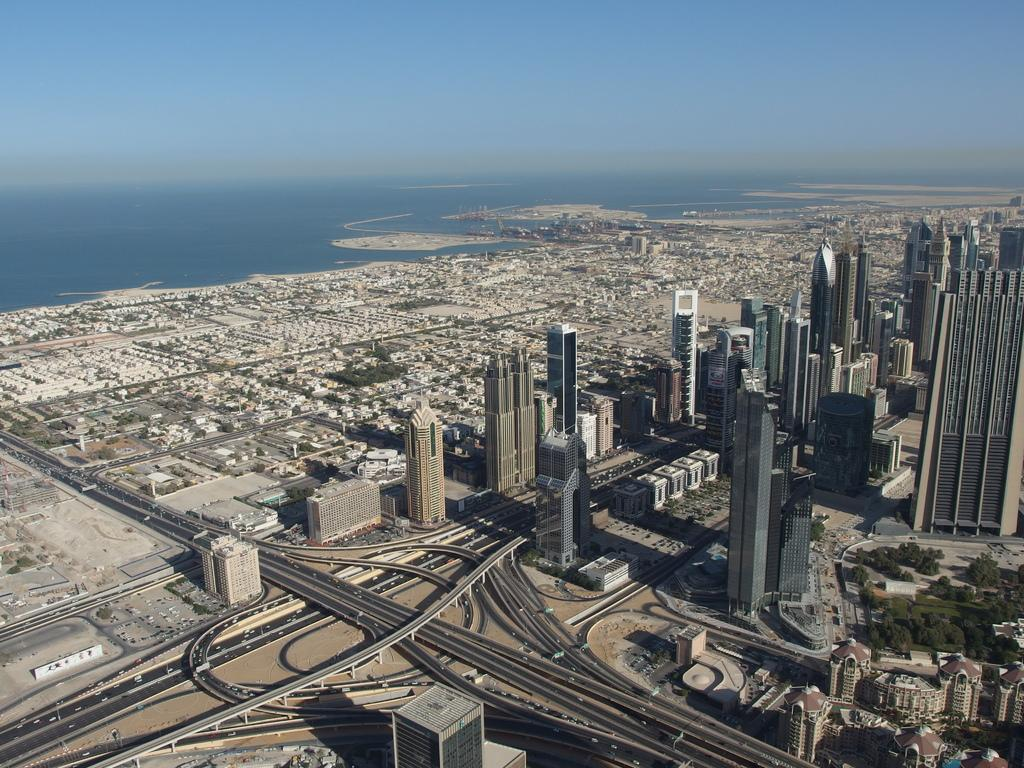What types of structures can be seen in the image? There are multiple buildings in the image. What other natural elements are present in the image? There are multiple trees in the image. What type of transportation infrastructure is visible in the image? There are roads visible in the image. What can be seen in the distance in the image? There is water visible in the background of the image, and the sky is also visible. Where is the sponge located in the image? There is no sponge present in the image. Can you describe the behavior of the ants in the image? There are no ants present in the image. 